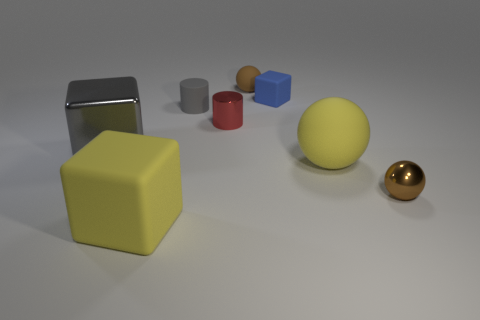What is the shape of the small gray object? The small gray object appears to be a cylinder, characterized by its circular base and straight, parallel sides, which are features that define cylindrical shapes. 